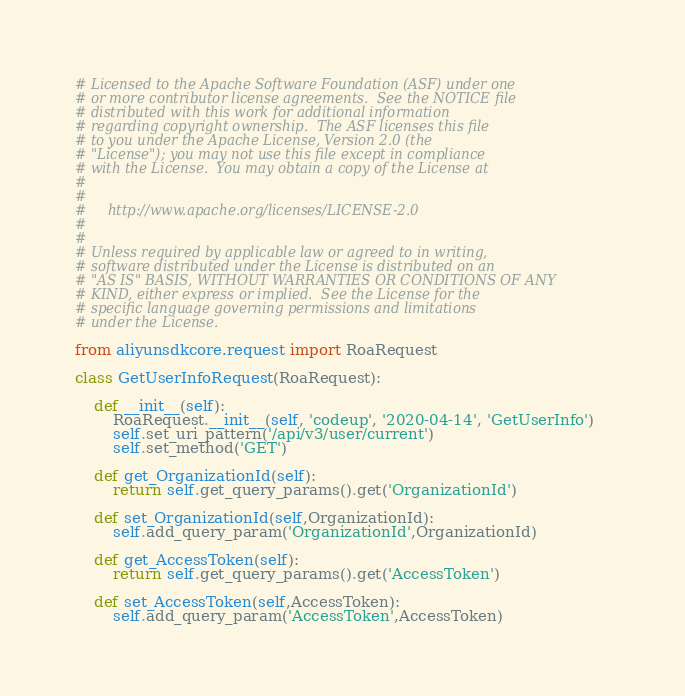Convert code to text. <code><loc_0><loc_0><loc_500><loc_500><_Python_># Licensed to the Apache Software Foundation (ASF) under one
# or more contributor license agreements.  See the NOTICE file
# distributed with this work for additional information
# regarding copyright ownership.  The ASF licenses this file
# to you under the Apache License, Version 2.0 (the
# "License"); you may not use this file except in compliance
# with the License.  You may obtain a copy of the License at
#
#
#     http://www.apache.org/licenses/LICENSE-2.0
#
#
# Unless required by applicable law or agreed to in writing,
# software distributed under the License is distributed on an
# "AS IS" BASIS, WITHOUT WARRANTIES OR CONDITIONS OF ANY
# KIND, either express or implied.  See the License for the
# specific language governing permissions and limitations
# under the License.

from aliyunsdkcore.request import RoaRequest

class GetUserInfoRequest(RoaRequest):

	def __init__(self):
		RoaRequest.__init__(self, 'codeup', '2020-04-14', 'GetUserInfo')
		self.set_uri_pattern('/api/v3/user/current')
		self.set_method('GET')

	def get_OrganizationId(self):
		return self.get_query_params().get('OrganizationId')

	def set_OrganizationId(self,OrganizationId):
		self.add_query_param('OrganizationId',OrganizationId)

	def get_AccessToken(self):
		return self.get_query_params().get('AccessToken')

	def set_AccessToken(self,AccessToken):
		self.add_query_param('AccessToken',AccessToken)</code> 